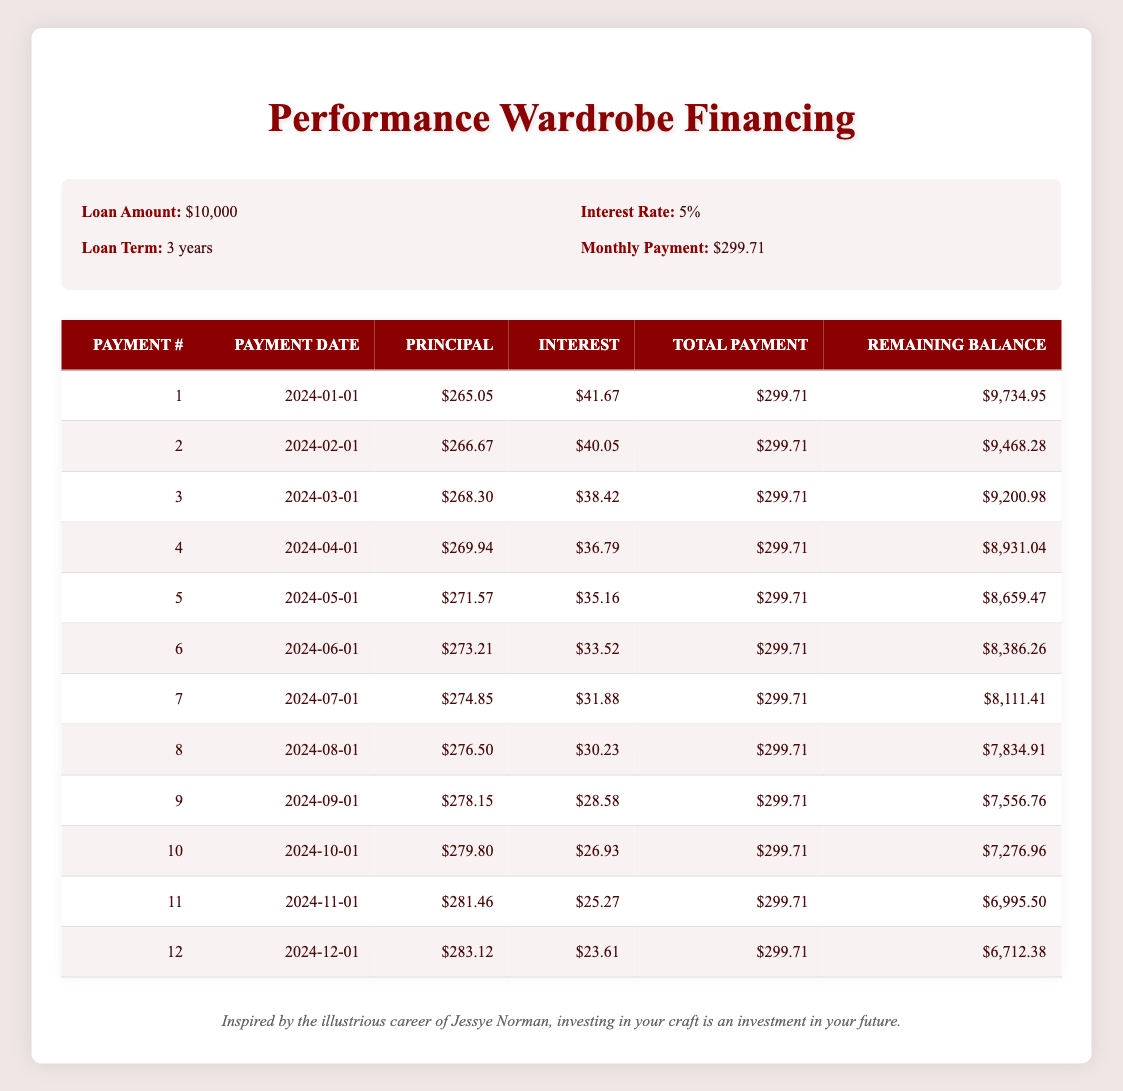What is the total amount paid after the first 3 payments? To find the total amount paid after the first 3 payments, we can sum the total payments from the first three rows: 299.71 + 299.71 + 299.71 = 899.13
Answer: 899.13 How much is the principal payment for the 5th payment? The principal payment for the 5th payment is directly listed in the table under the "Principal" column for payment number 5, which is 271.57
Answer: 271.57 Is the interest payment for the 2nd payment greater than that of the 4th payment? Referring to the table, the interest payment for the 2nd payment is 40.05 and for the 4th payment is 36.79. Since 40.05 is greater than 36.79, the answer is yes
Answer: Yes What is the average monthly interest payment for the first 6 payments? First, we find the total interest paid for the first 6 payments by adding the interest payments: 41.67 + 40.05 + 38.42 + 36.79 + 35.16 + 33.52 = 225.61. Then, we divide by 6 to find the average: 225.61 / 6 = 37.60
Answer: 37.60 What is the remaining balance after the 12th payment? The remaining balance after the 12th payment is found in the last row of the table under "Remaining Balance," which shows 6,712.38
Answer: 6,712.38 How much did the remaining balance decrease from the 1st payment to the 12th payment? The remaining balance after the 1st payment is 9,734.95 and after the 12th payment it is 6,712.38. To find the decrease: 9,734.95 - 6,712.38 = 3,022.57
Answer: 3,022.57 Do the total payments for the 10th payment include both principal and interest? The total payment for the 10th payment is 299.71, which includes both the principal payment of 279.80 and the interest payment of 26.93. Therefore, the answer is yes
Answer: Yes What is the smallest principal payment made in the first 3 payments? The principal payments for the first three payments are 265.05, 266.67, and 268.30. The smallest among these is 265.05
Answer: 265.05 